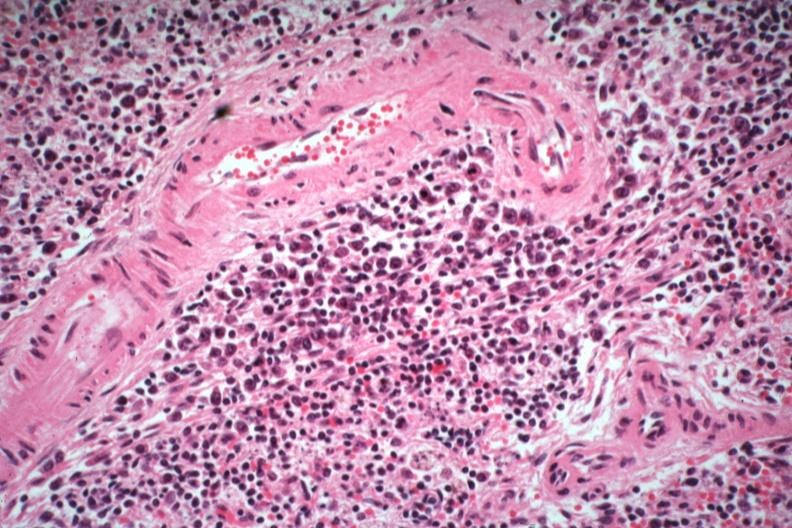what does this image show?
Answer the question using a single word or phrase. Numerous atypical cells around splenic arteriole man died of what was thought to be viral pneumonia probably influenza 